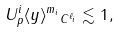Convert formula to latex. <formula><loc_0><loc_0><loc_500><loc_500>\| U ^ { i } _ { p } \langle y \rangle ^ { m _ { i } } \| _ { C ^ { \ell _ { i } } } \lesssim 1 ,</formula> 